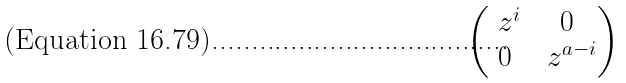<formula> <loc_0><loc_0><loc_500><loc_500>\begin{pmatrix} \ z ^ { i } & 0 \\ 0 & \ z ^ { a - i } \end{pmatrix}</formula> 